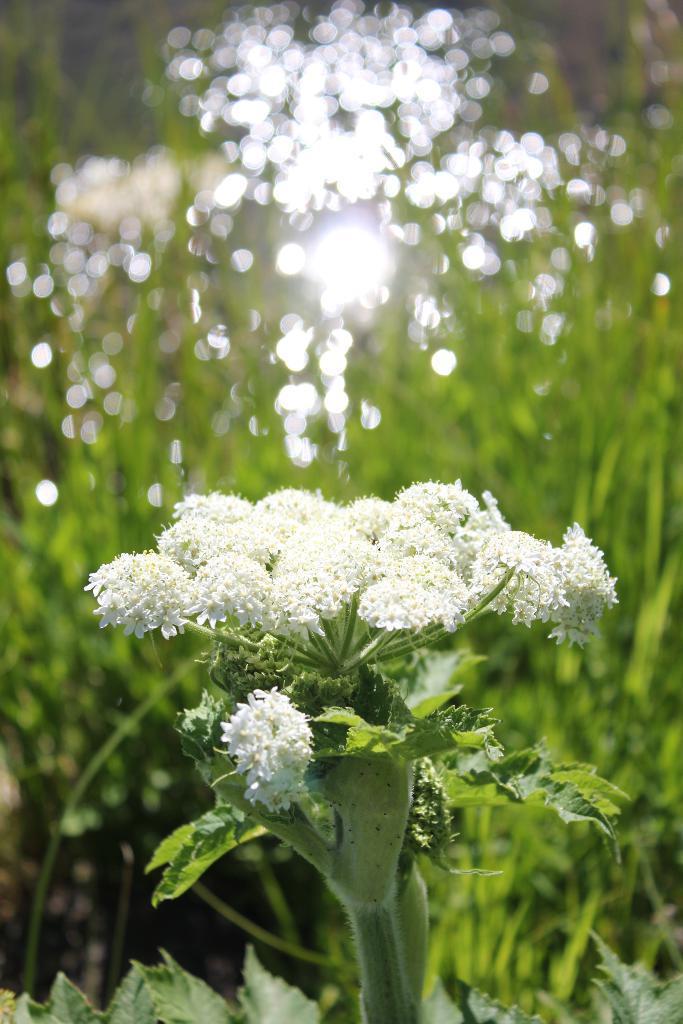In one or two sentences, can you explain what this image depicts? In this image, there is a plant contains some flowers. In the background, image is blurred. 